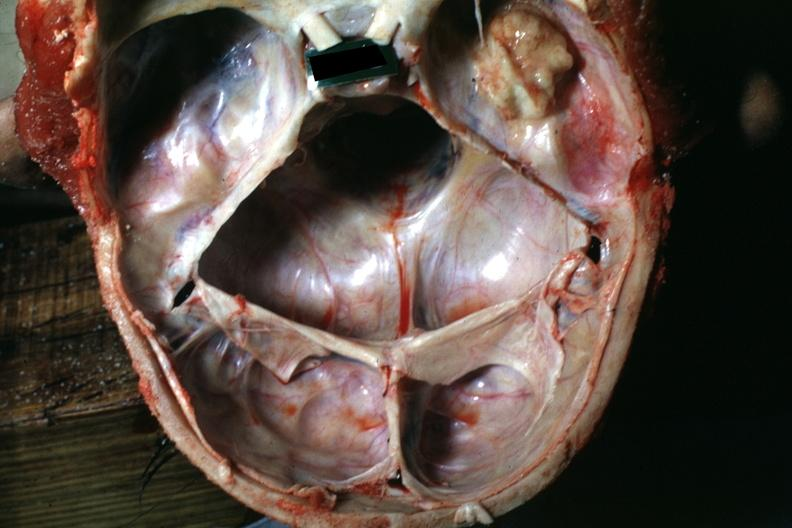what is present?
Answer the question using a single word or phrase. Bone, calvarium 